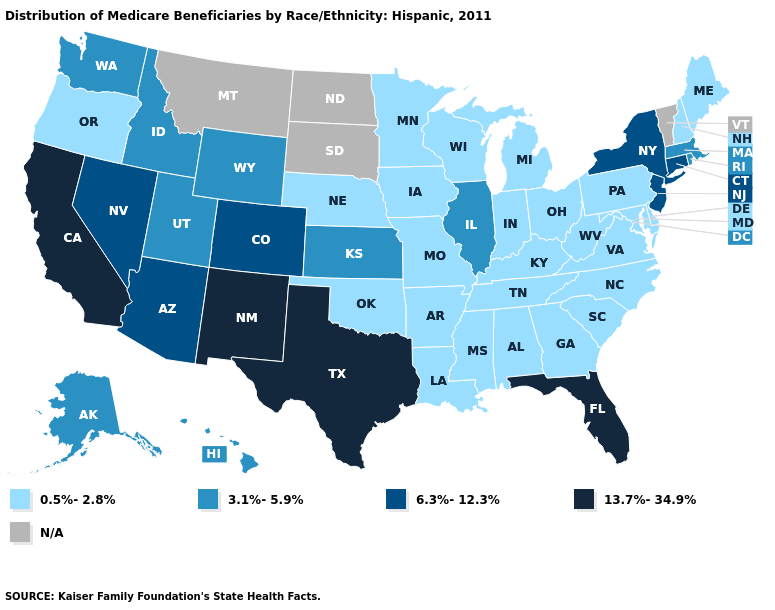Which states have the lowest value in the West?
Concise answer only. Oregon. Which states have the highest value in the USA?
Answer briefly. California, Florida, New Mexico, Texas. What is the lowest value in the USA?
Answer briefly. 0.5%-2.8%. Among the states that border Nebraska , which have the highest value?
Write a very short answer. Colorado. What is the value of Montana?
Answer briefly. N/A. What is the value of New York?
Be succinct. 6.3%-12.3%. Which states have the lowest value in the USA?
Short answer required. Alabama, Arkansas, Delaware, Georgia, Indiana, Iowa, Kentucky, Louisiana, Maine, Maryland, Michigan, Minnesota, Mississippi, Missouri, Nebraska, New Hampshire, North Carolina, Ohio, Oklahoma, Oregon, Pennsylvania, South Carolina, Tennessee, Virginia, West Virginia, Wisconsin. Name the states that have a value in the range 3.1%-5.9%?
Quick response, please. Alaska, Hawaii, Idaho, Illinois, Kansas, Massachusetts, Rhode Island, Utah, Washington, Wyoming. Name the states that have a value in the range 13.7%-34.9%?
Be succinct. California, Florida, New Mexico, Texas. What is the value of New Hampshire?
Be succinct. 0.5%-2.8%. Among the states that border Delaware , does New Jersey have the highest value?
Write a very short answer. Yes. Name the states that have a value in the range 3.1%-5.9%?
Be succinct. Alaska, Hawaii, Idaho, Illinois, Kansas, Massachusetts, Rhode Island, Utah, Washington, Wyoming. What is the value of Oregon?
Concise answer only. 0.5%-2.8%. 